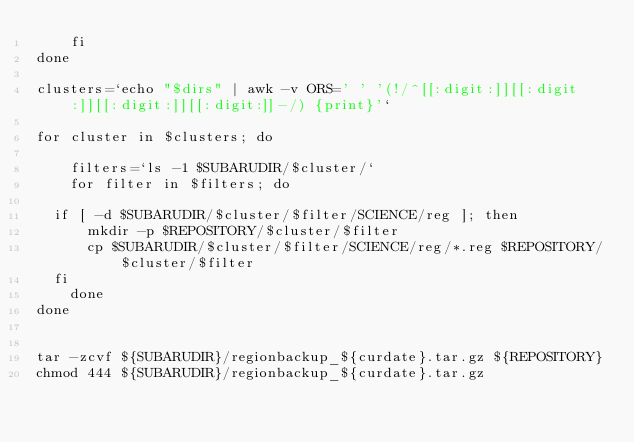Convert code to text. <code><loc_0><loc_0><loc_500><loc_500><_Bash_>    fi
done

clusters=`echo "$dirs" | awk -v ORS=' ' '(!/^[[:digit:]][[:digit:]][[:digit:]][[:digit:]]-/) {print}'`

for cluster in $clusters; do

    filters=`ls -1 $SUBARUDIR/$cluster/`
    for filter in $filters; do
	
	if [ -d $SUBARUDIR/$cluster/$filter/SCIENCE/reg ]; then
	    mkdir -p $REPOSITORY/$cluster/$filter
	    cp $SUBARUDIR/$cluster/$filter/SCIENCE/reg/*.reg $REPOSITORY/$cluster/$filter
	fi
    done
done


tar -zcvf ${SUBARUDIR}/regionbackup_${curdate}.tar.gz ${REPOSITORY}
chmod 444 ${SUBARUDIR}/regionbackup_${curdate}.tar.gz</code> 